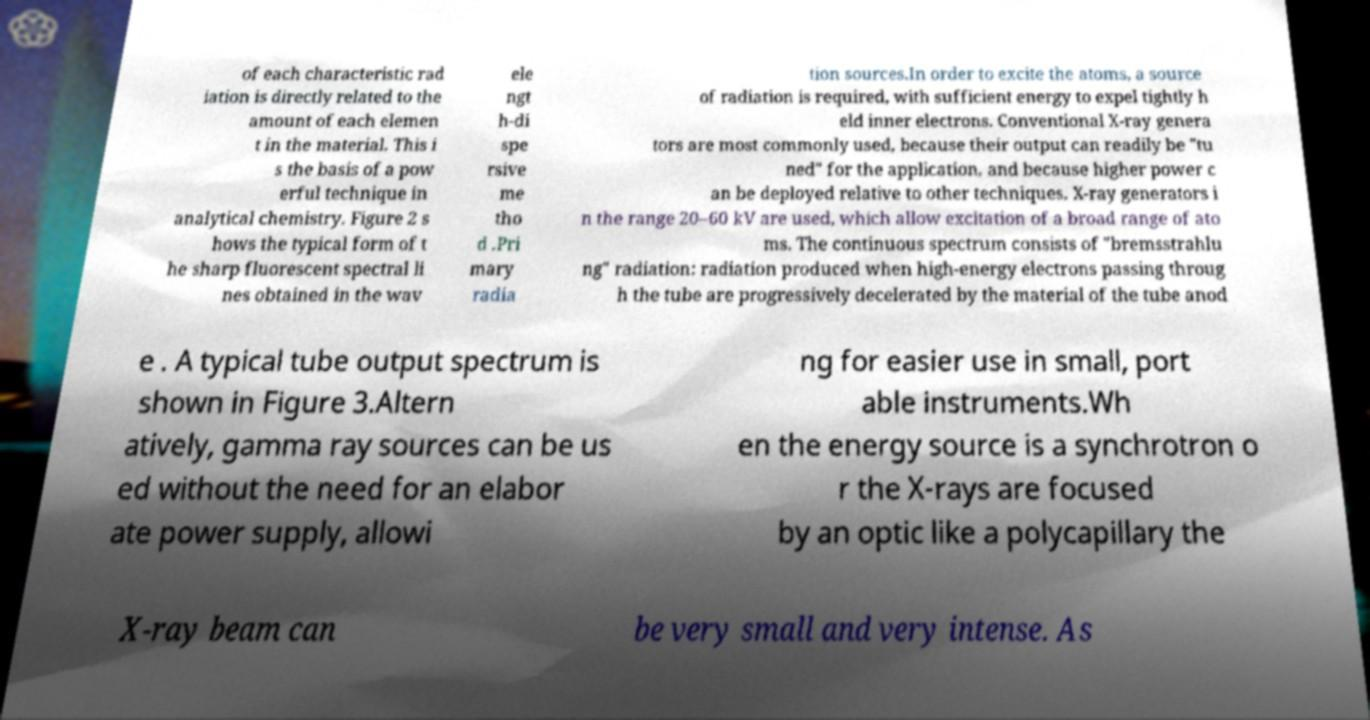For documentation purposes, I need the text within this image transcribed. Could you provide that? of each characteristic rad iation is directly related to the amount of each elemen t in the material. This i s the basis of a pow erful technique in analytical chemistry. Figure 2 s hows the typical form of t he sharp fluorescent spectral li nes obtained in the wav ele ngt h-di spe rsive me tho d .Pri mary radia tion sources.In order to excite the atoms, a source of radiation is required, with sufficient energy to expel tightly h eld inner electrons. Conventional X-ray genera tors are most commonly used, because their output can readily be "tu ned" for the application, and because higher power c an be deployed relative to other techniques. X-ray generators i n the range 20–60 kV are used, which allow excitation of a broad range of ato ms. The continuous spectrum consists of "bremsstrahlu ng" radiation: radiation produced when high-energy electrons passing throug h the tube are progressively decelerated by the material of the tube anod e . A typical tube output spectrum is shown in Figure 3.Altern atively, gamma ray sources can be us ed without the need for an elabor ate power supply, allowi ng for easier use in small, port able instruments.Wh en the energy source is a synchrotron o r the X-rays are focused by an optic like a polycapillary the X-ray beam can be very small and very intense. As 